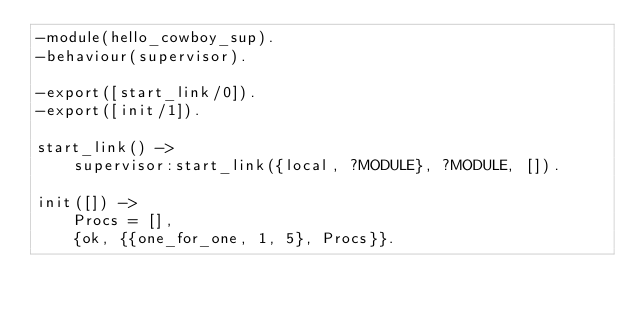Convert code to text. <code><loc_0><loc_0><loc_500><loc_500><_Erlang_>-module(hello_cowboy_sup).
-behaviour(supervisor).

-export([start_link/0]).
-export([init/1]).

start_link() ->
	supervisor:start_link({local, ?MODULE}, ?MODULE, []).

init([]) ->
	Procs = [],
	{ok, {{one_for_one, 1, 5}, Procs}}.
</code> 